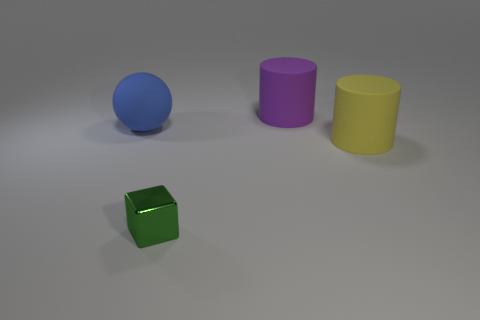Add 1 blue matte spheres. How many objects exist? 5 Subtract all cubes. How many objects are left? 3 Subtract all large yellow cylinders. Subtract all large blue balls. How many objects are left? 2 Add 3 tiny green metallic blocks. How many tiny green metallic blocks are left? 4 Add 2 small brown rubber cylinders. How many small brown rubber cylinders exist? 2 Subtract 0 blue cylinders. How many objects are left? 4 